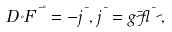Convert formula to latex. <formula><loc_0><loc_0><loc_500><loc_500>D _ { \nu } F ^ { \mu \nu } = - j ^ { \mu } , j ^ { \mu } = g \bar { \psi } \gamma ^ { \mu } \psi ,</formula> 